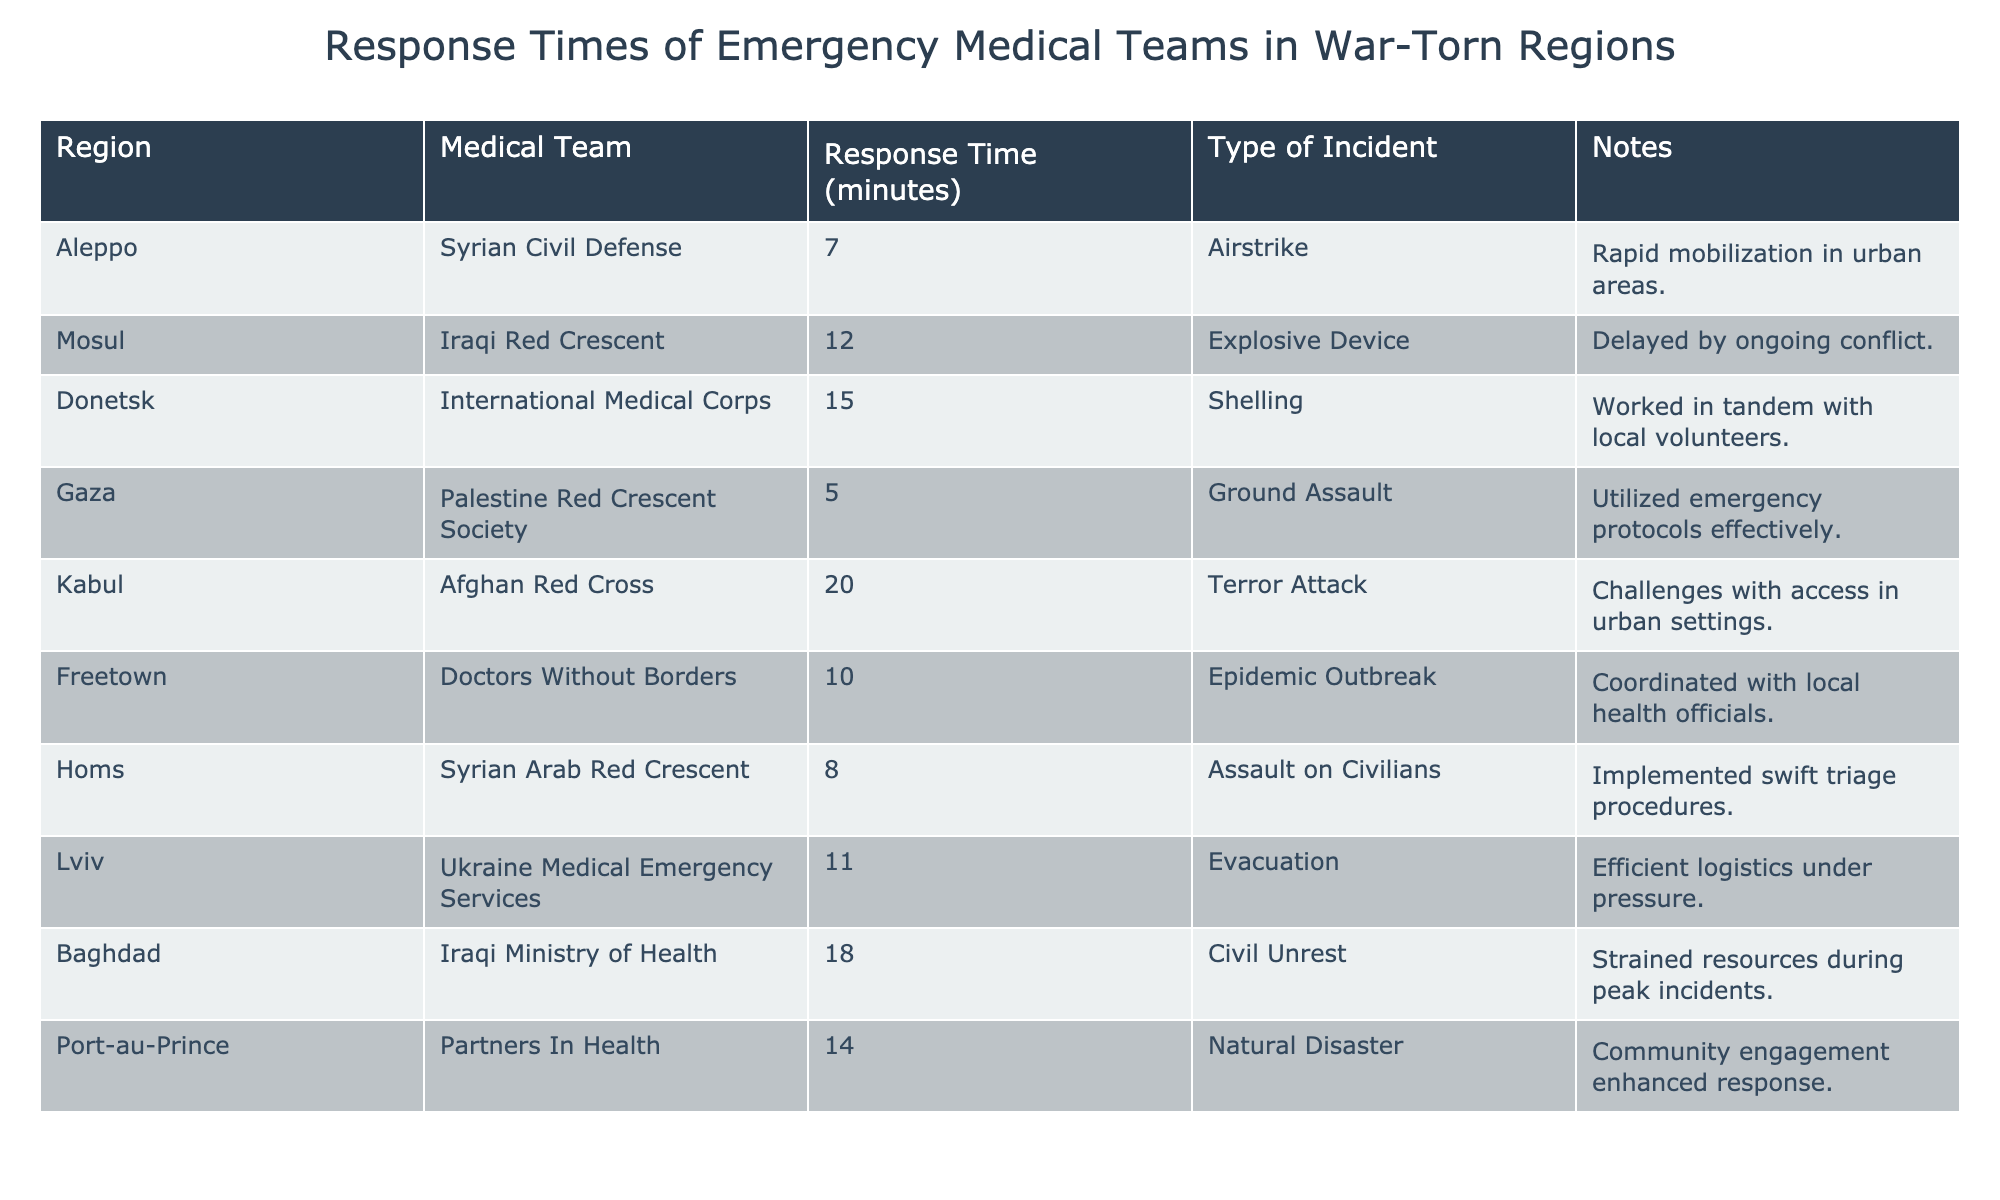What is the response time of the Syrian Civil Defense in Aleppo? The table directly states that the response time for the Syrian Civil Defense in Aleppo is 7 minutes.
Answer: 7 minutes Which medical team had the longest response time? By reviewing the response times in the table, the Afghan Red Cross in Kabul had the longest response time of 20 minutes.
Answer: 20 minutes What is the average response time of the emergency medical teams listed? To find the average, we add all response times: (7 + 12 + 15 + 5 + 20 + 10 + 8 + 11 + 18 + 14) = 125. Since there are 10 teams, we divide 125 by 10, which results in 12.5 minutes.
Answer: 12.5 minutes Did the Palestine Red Crescent Society respond the quickest? According to the table, the Palestine Red Crescent Society had a response time of 5 minutes, which is indeed the quickest among all teams listed.
Answer: Yes How many medical teams had response times of 10 minutes or less? The medical teams with response times of 10 minutes or less include Syrian Civil Defense (7), Palestine Red Crescent Society (5), and Syrian Arab Red Crescent (8). Therefore, there are three teams that had response times of 10 minutes or less.
Answer: 3 teams Which region had a delayed response due to ongoing conflict? The Iraqi Red Crescent in Mosul experienced a delayed response of 12 minutes, specifically due to ongoing conflict in the area.
Answer: Mosul What is the difference in response time between the quickest and the slowest medical team? The quickest medical team, Palestine Red Crescent Society, had a response time of 5 minutes, while the slowest, Afghan Red Cross, had 20 minutes. The difference is calculated as 20 - 5 = 15 minutes.
Answer: 15 minutes Do any medical teams specifically mention community engagement in their notes? The table indicates that Partners In Health in Port-au-Prince noted community engagement as enhancing their response. Therefore, they do mention it.
Answer: Yes What response time was recorded for the International Medical Corps in Donetsk? Directly derived from the table, the International Medical Corps in Donetsk had a recorded response time of 15 minutes.
Answer: 15 minutes 